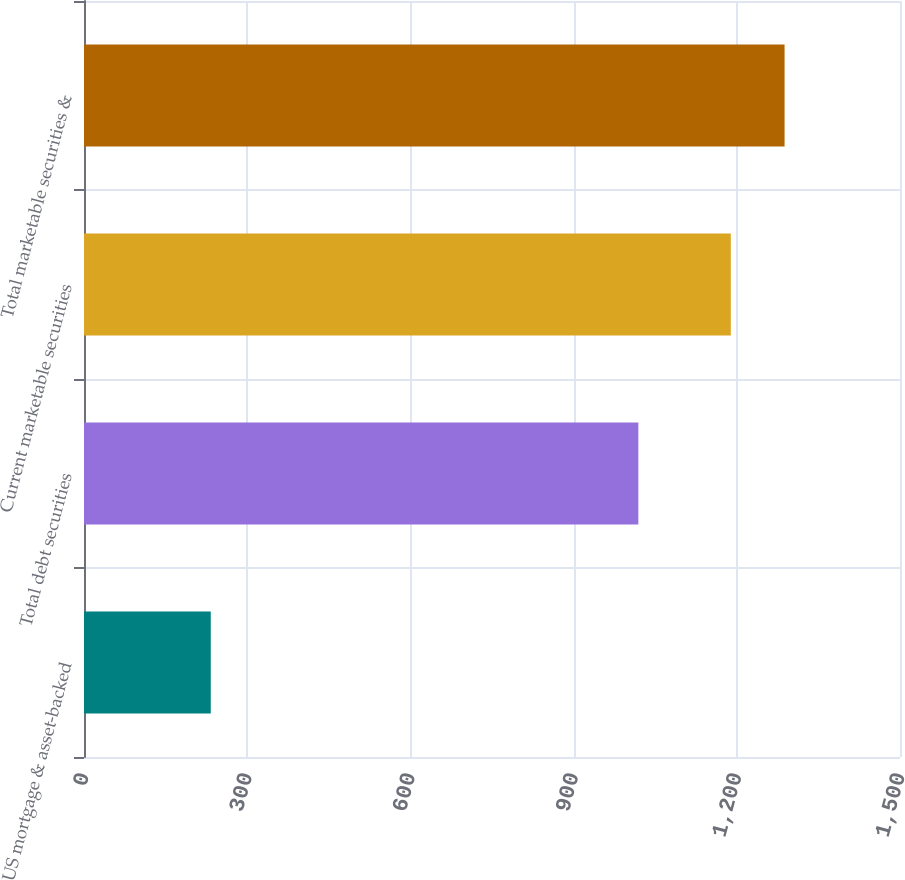<chart> <loc_0><loc_0><loc_500><loc_500><bar_chart><fcel>US mortgage & asset-backed<fcel>Total debt securities<fcel>Current marketable securities<fcel>Total marketable securities &<nl><fcel>233<fcel>1019<fcel>1189<fcel>1287.8<nl></chart> 